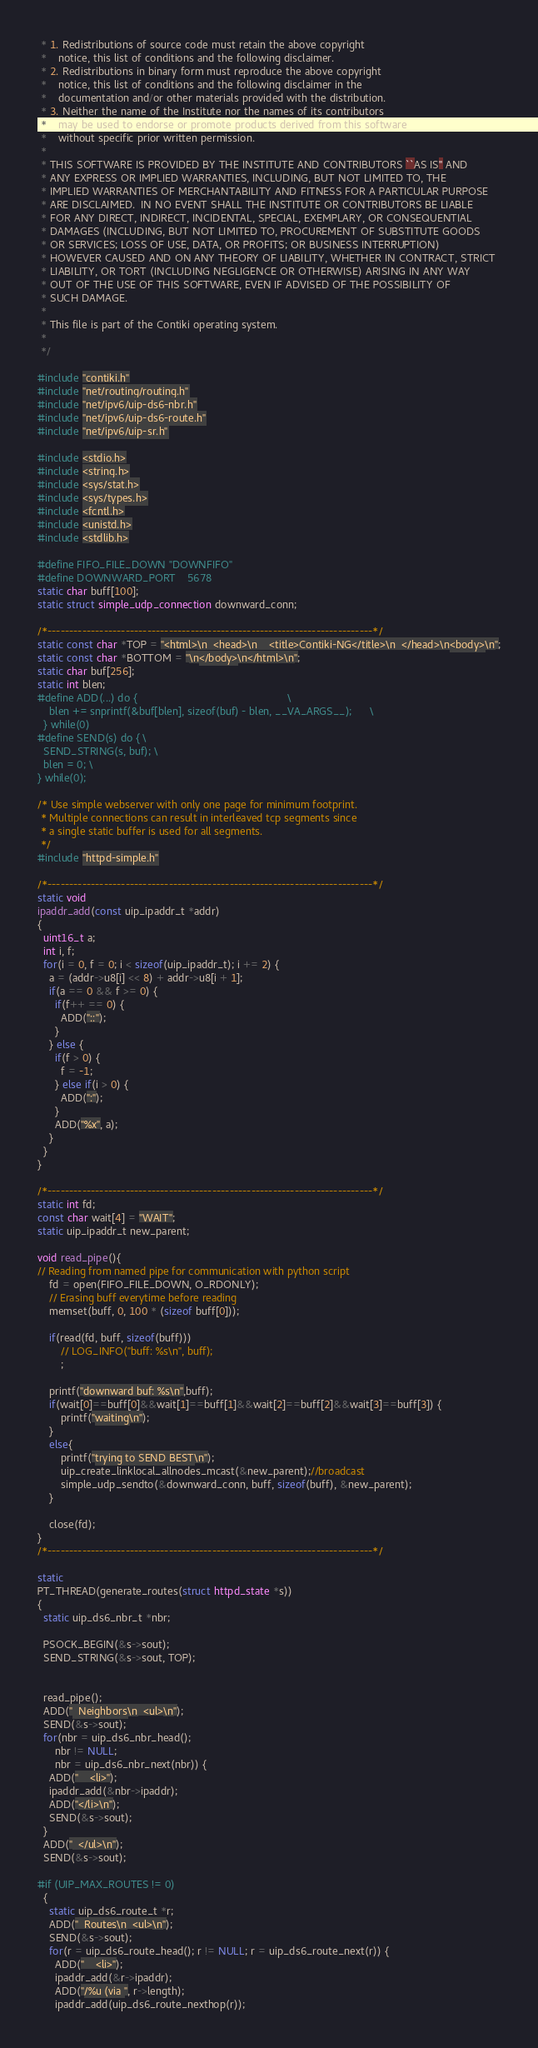<code> <loc_0><loc_0><loc_500><loc_500><_C_> * 1. Redistributions of source code must retain the above copyright
 *    notice, this list of conditions and the following disclaimer.
 * 2. Redistributions in binary form must reproduce the above copyright
 *    notice, this list of conditions and the following disclaimer in the
 *    documentation and/or other materials provided with the distribution.
 * 3. Neither the name of the Institute nor the names of its contributors
 *    may be used to endorse or promote products derived from this software
 *    without specific prior written permission.
 *
 * THIS SOFTWARE IS PROVIDED BY THE INSTITUTE AND CONTRIBUTORS ``AS IS'' AND
 * ANY EXPRESS OR IMPLIED WARRANTIES, INCLUDING, BUT NOT LIMITED TO, THE
 * IMPLIED WARRANTIES OF MERCHANTABILITY AND FITNESS FOR A PARTICULAR PURPOSE
 * ARE DISCLAIMED.  IN NO EVENT SHALL THE INSTITUTE OR CONTRIBUTORS BE LIABLE
 * FOR ANY DIRECT, INDIRECT, INCIDENTAL, SPECIAL, EXEMPLARY, OR CONSEQUENTIAL
 * DAMAGES (INCLUDING, BUT NOT LIMITED TO, PROCUREMENT OF SUBSTITUTE GOODS
 * OR SERVICES; LOSS OF USE, DATA, OR PROFITS; OR BUSINESS INTERRUPTION)
 * HOWEVER CAUSED AND ON ANY THEORY OF LIABILITY, WHETHER IN CONTRACT, STRICT
 * LIABILITY, OR TORT (INCLUDING NEGLIGENCE OR OTHERWISE) ARISING IN ANY WAY
 * OUT OF THE USE OF THIS SOFTWARE, EVEN IF ADVISED OF THE POSSIBILITY OF
 * SUCH DAMAGE.
 *
 * This file is part of the Contiki operating system.
 *
 */

#include "contiki.h"
#include "net/routing/routing.h"
#include "net/ipv6/uip-ds6-nbr.h"
#include "net/ipv6/uip-ds6-route.h"
#include "net/ipv6/uip-sr.h"

#include <stdio.h>
#include <string.h>
#include <sys/stat.h>
#include <sys/types.h>
#include <fcntl.h>
#include <unistd.h>
#include <stdlib.h>

#define FIFO_FILE_DOWN "DOWNFIFO"
#define DOWNWARD_PORT	5678
static char buff[100];
static struct simple_udp_connection downward_conn;

/*---------------------------------------------------------------------------*/
static const char *TOP = "<html>\n  <head>\n    <title>Contiki-NG</title>\n  </head>\n<body>\n";
static const char *BOTTOM = "\n</body>\n</html>\n";
static char buf[256];
static int blen;
#define ADD(...) do {                                                   \
    blen += snprintf(&buf[blen], sizeof(buf) - blen, __VA_ARGS__);      \
  } while(0)
#define SEND(s) do { \
  SEND_STRING(s, buf); \
  blen = 0; \
} while(0);

/* Use simple webserver with only one page for minimum footprint.
 * Multiple connections can result in interleaved tcp segments since
 * a single static buffer is used for all segments.
 */
#include "httpd-simple.h"

/*---------------------------------------------------------------------------*/
static void
ipaddr_add(const uip_ipaddr_t *addr)
{
  uint16_t a;
  int i, f;
  for(i = 0, f = 0; i < sizeof(uip_ipaddr_t); i += 2) {
    a = (addr->u8[i] << 8) + addr->u8[i + 1];
    if(a == 0 && f >= 0) {
      if(f++ == 0) {
        ADD("::");
      }
    } else {
      if(f > 0) {
        f = -1;
      } else if(i > 0) {
        ADD(":");
      }
      ADD("%x", a);
    }
  }
}

/*---------------------------------------------------------------------------*/
static int fd;
const char wait[4] = "WAIT";
static uip_ipaddr_t new_parent;

void read_pipe(){
// Reading from named pipe for communication with python script
    fd = open(FIFO_FILE_DOWN, O_RDONLY);
    // Erasing buff everytime before reading
    memset(buff, 0, 100 * (sizeof buff[0]));

    if(read(fd, buff, sizeof(buff)))
        // LOG_INFO("buff: %s\n", buff);
        ;
		
    printf("downward buf: %s\n",buff);
    if(wait[0]==buff[0]&&wait[1]==buff[1]&&wait[2]==buff[2]&&wait[3]==buff[3]) {
        printf("waiting\n");
    }
    else{
        printf("trying to SEND BEST\n");
        uip_create_linklocal_allnodes_mcast(&new_parent);//broadcast
        simple_udp_sendto(&downward_conn, buff, sizeof(buff), &new_parent);  
    }

    close(fd);
}
/*---------------------------------------------------------------------------*/

static
PT_THREAD(generate_routes(struct httpd_state *s))
{
  static uip_ds6_nbr_t *nbr;

  PSOCK_BEGIN(&s->sout);
  SEND_STRING(&s->sout, TOP);


  read_pipe();
  ADD("  Neighbors\n  <ul>\n");
  SEND(&s->sout);
  for(nbr = uip_ds6_nbr_head();
      nbr != NULL;
      nbr = uip_ds6_nbr_next(nbr)) {
    ADD("    <li>");
    ipaddr_add(&nbr->ipaddr);
    ADD("</li>\n");
    SEND(&s->sout);
  }
  ADD("  </ul>\n");
  SEND(&s->sout);

#if (UIP_MAX_ROUTES != 0)
  {
    static uip_ds6_route_t *r;
    ADD("  Routes\n  <ul>\n");
    SEND(&s->sout);
    for(r = uip_ds6_route_head(); r != NULL; r = uip_ds6_route_next(r)) {
      ADD("    <li>");
      ipaddr_add(&r->ipaddr);
      ADD("/%u (via ", r->length);
      ipaddr_add(uip_ds6_route_nexthop(r));</code> 